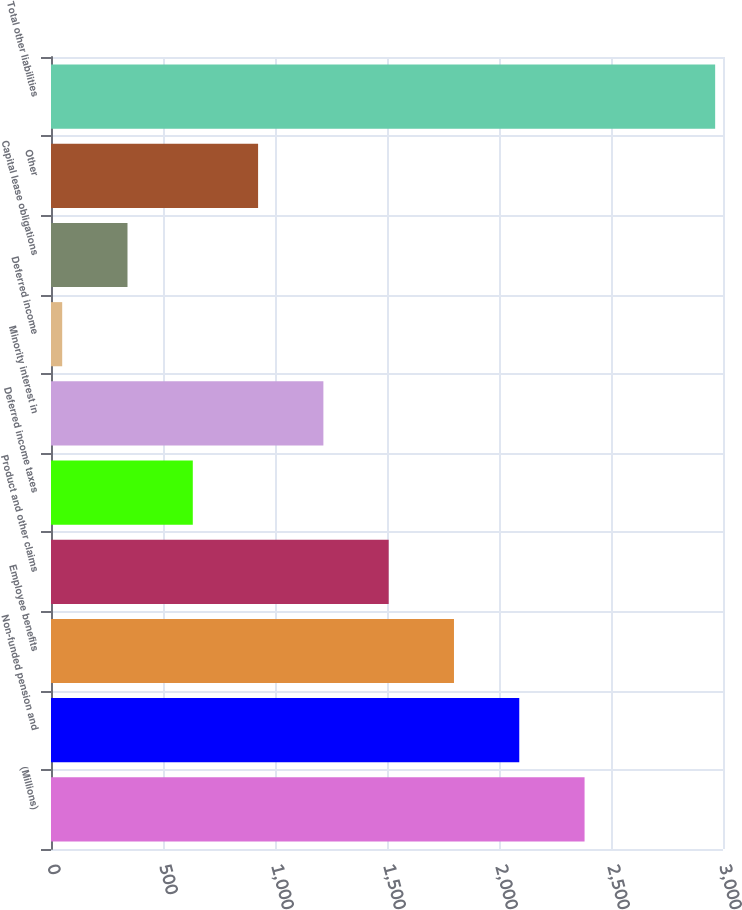Convert chart to OTSL. <chart><loc_0><loc_0><loc_500><loc_500><bar_chart><fcel>(Millions)<fcel>Non-funded pension and<fcel>Employee benefits<fcel>Product and other claims<fcel>Deferred income taxes<fcel>Minority interest in<fcel>Deferred income<fcel>Capital lease obligations<fcel>Other<fcel>Total other liabilities<nl><fcel>2382<fcel>2090.5<fcel>1799<fcel>1507.5<fcel>633<fcel>1216<fcel>50<fcel>341.5<fcel>924.5<fcel>2965<nl></chart> 